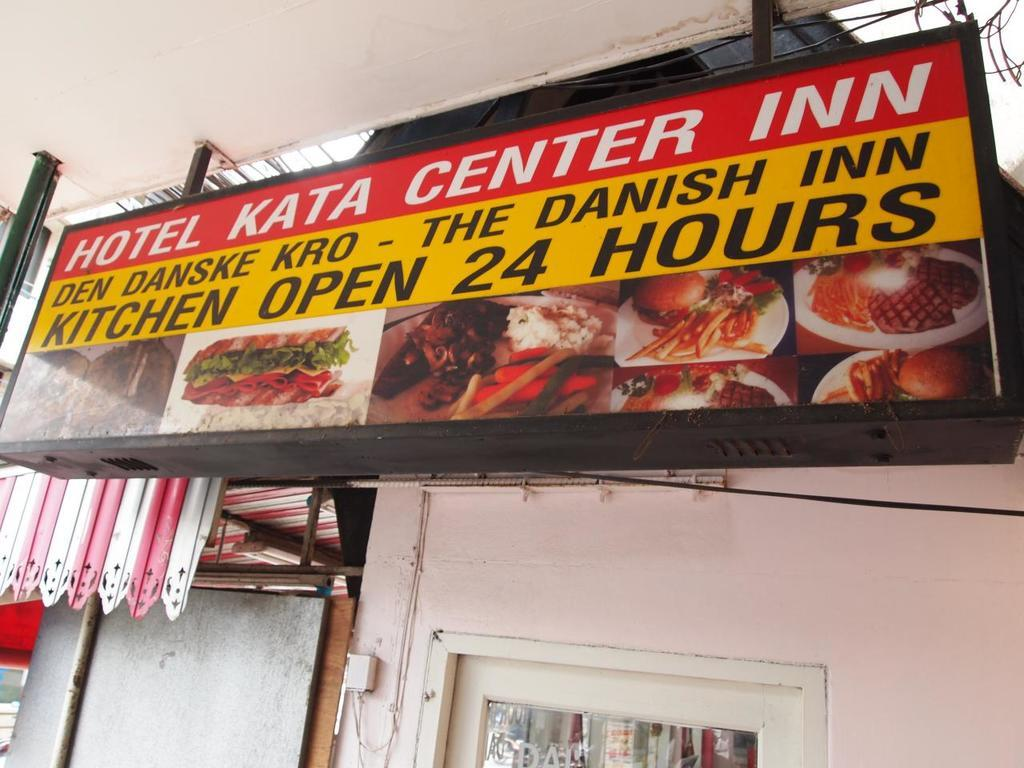What is the main subject in the middle of the image? There is a hoarding in the middle of the image. What else can be seen in the image besides the hoarding? There is a wall in the image. Can you describe the wall in the image? There is a window at the bottom of the wall. What type of thunder can be heard coming from the hoarding in the image? There is no thunder present in the image, as it is a static hoarding. 